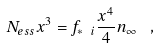<formula> <loc_0><loc_0><loc_500><loc_500>N _ { e s s } x ^ { 3 } = f _ { * \ i } \frac { x ^ { 4 } } { 4 } n _ { \infty } \ \ ,</formula> 